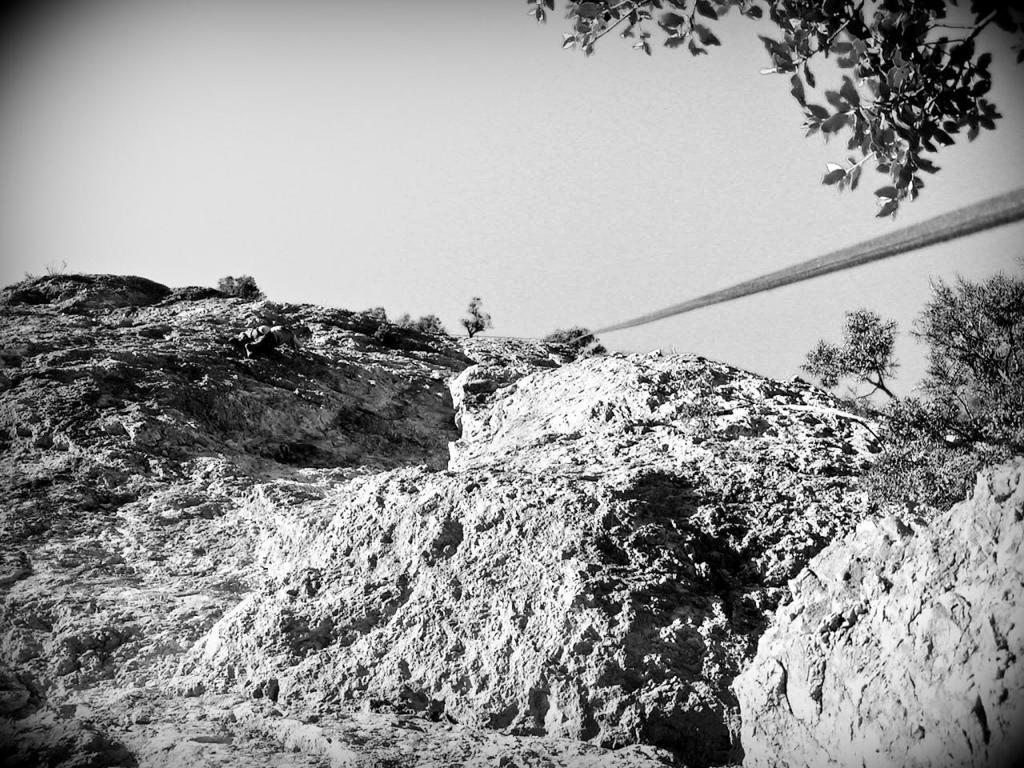What type of picture is in the image? The image contains a black and white picture. What is the subject of the picture? The picture depicts a rocky mountain. Are there any plants visible on the mountain? Yes, there are trees on the mountain. What else can be seen in the image? A rope is present in the image. What is visible in the background of the picture? The sky is visible in the background of the image. How many children are playing with the stitch on the mountain in the image? There are no children or stitch present in the image; it features a black and white picture of a rocky mountain with trees and a rope. 